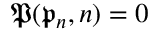Convert formula to latex. <formula><loc_0><loc_0><loc_500><loc_500>\mathfrak { P } ( \mathfrak { p } _ { n } , n ) = 0</formula> 